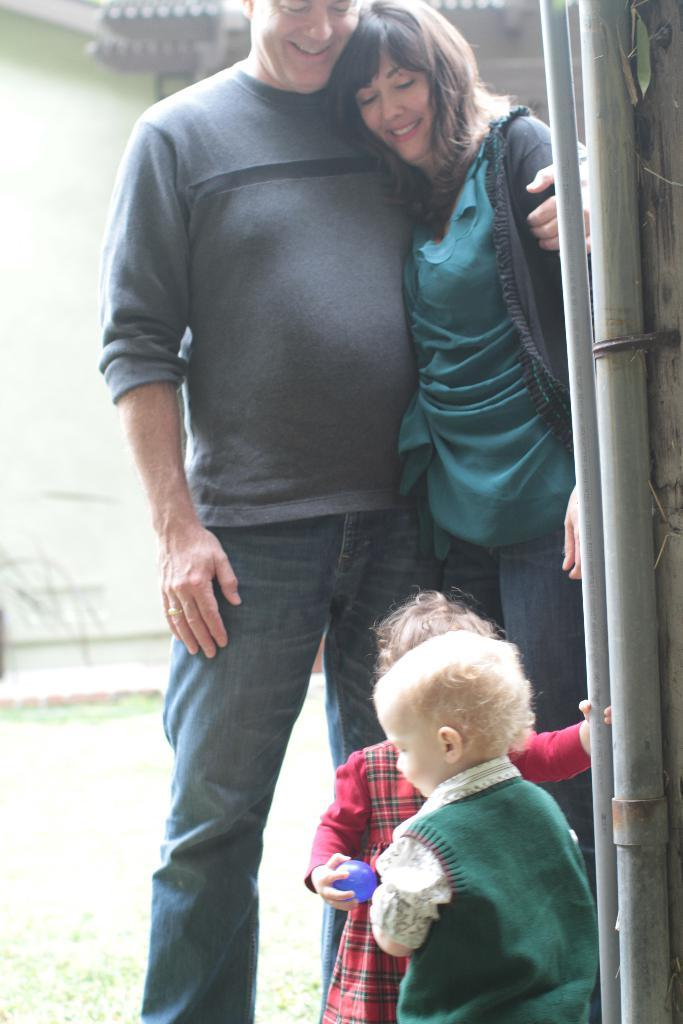How many people are present in the image? There are four people standing in the image. What is the surface on which the people are standing? The people are standing on grass. What object is in front of the people? There is a pipe in front of the people. What can be seen in the background of the image? There is a wall in the background of the image. What type of office can be seen in the image? There is no office present in the image; it features four people standing on grass with a pipe in front of them and a wall in the background. 